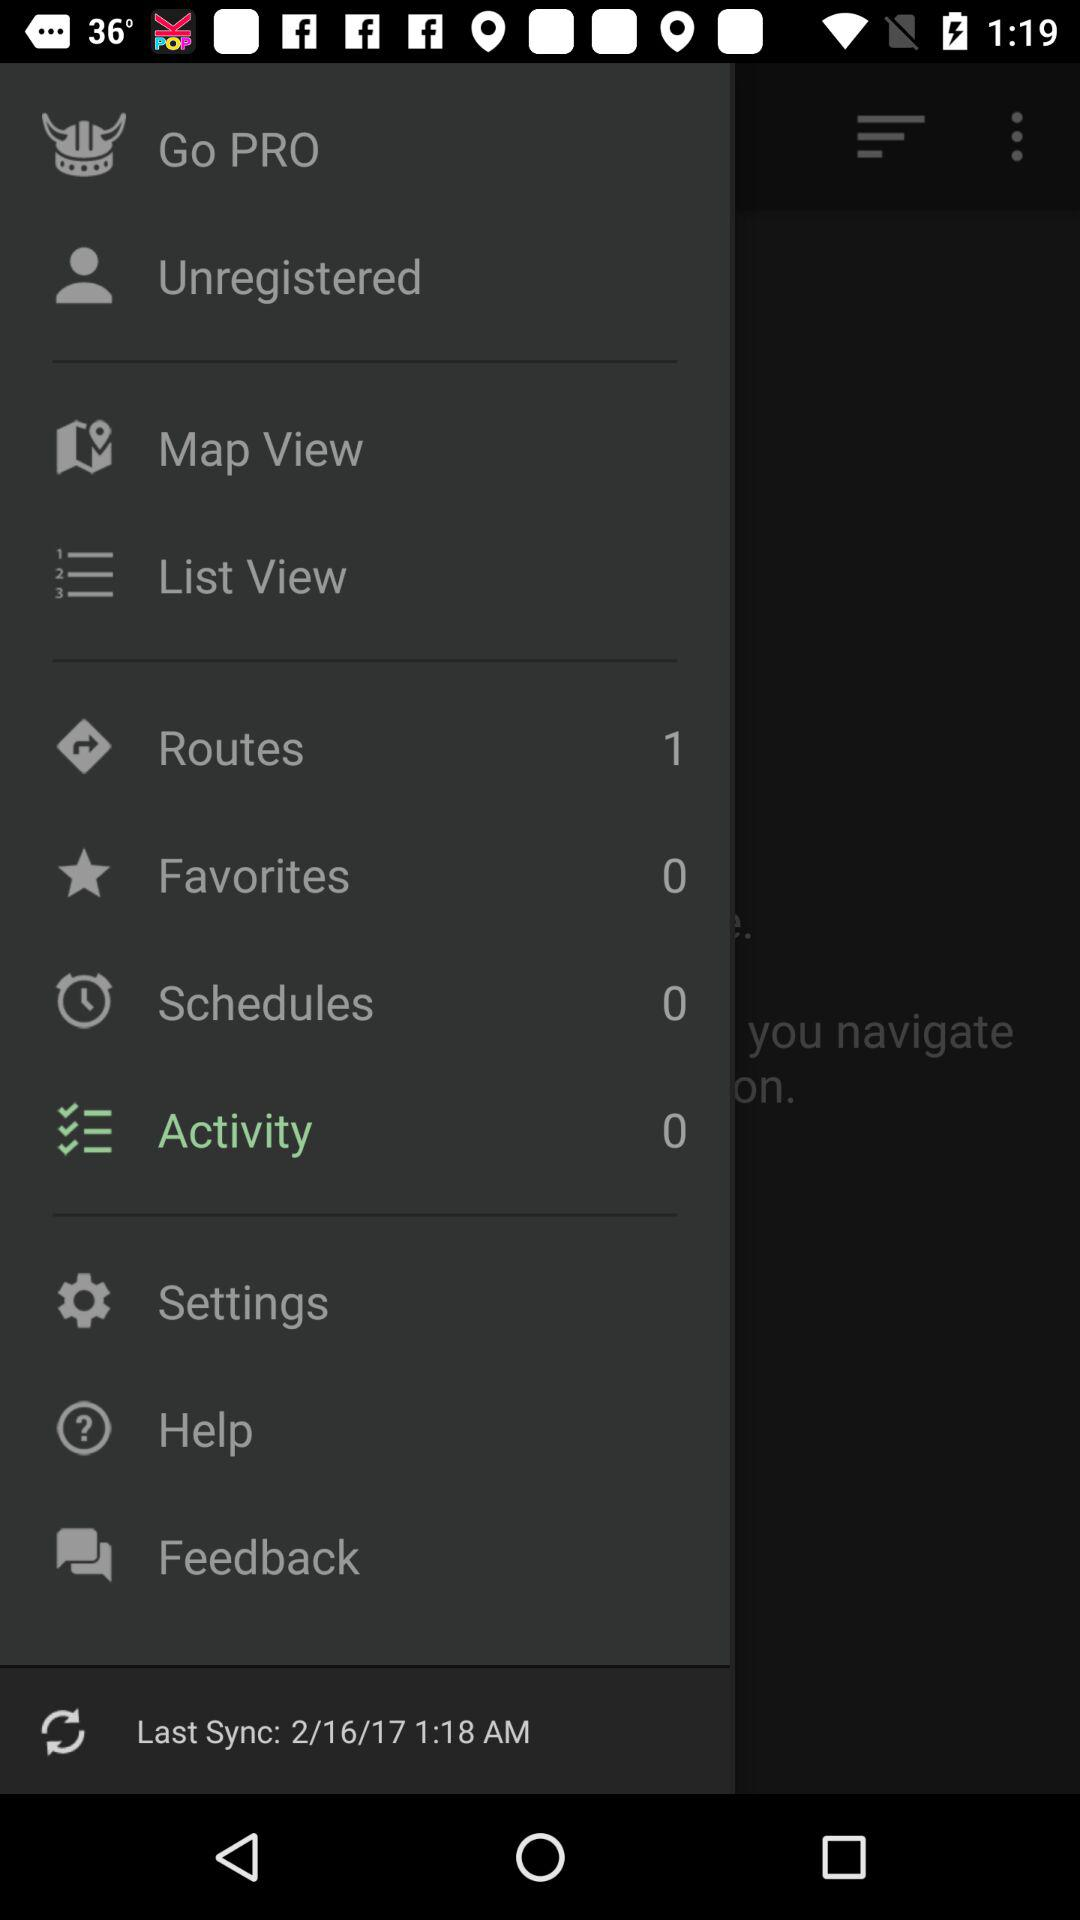When was it last synced? It was last synced on February 16, 2017 at 1:18 AM. 